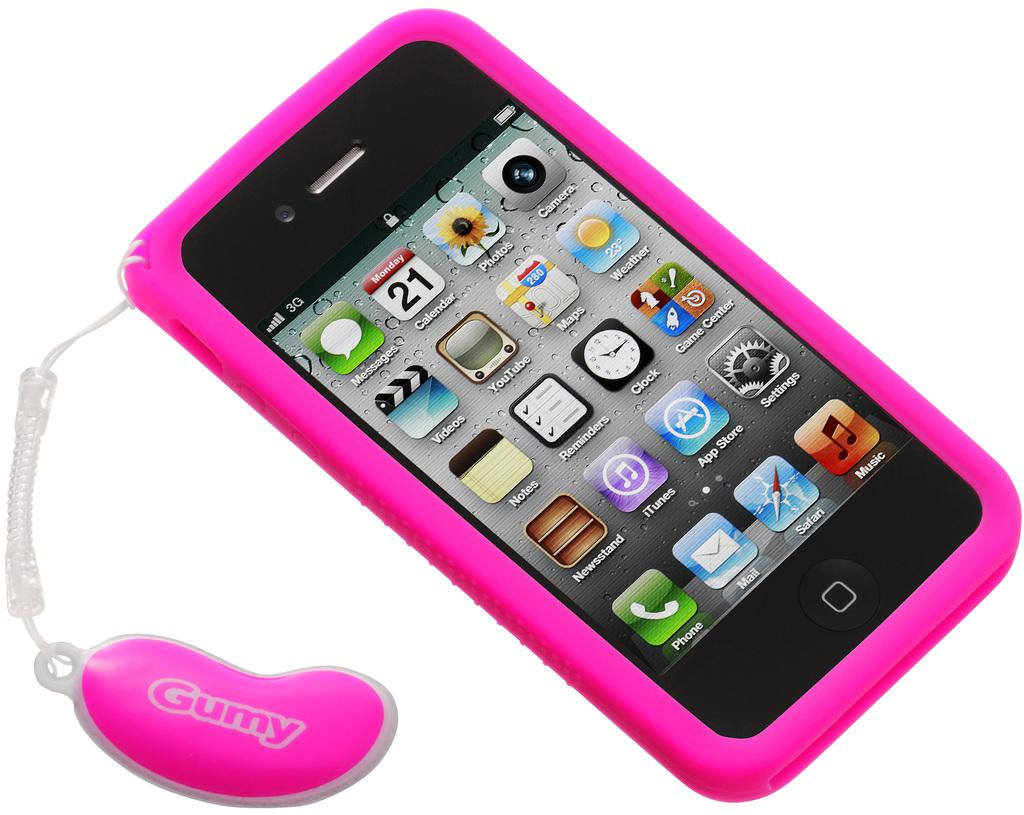Provide a one-sentence caption for the provided image. A pink smart phone with the number 21 visible on it. 